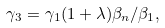Convert formula to latex. <formula><loc_0><loc_0><loc_500><loc_500>\gamma _ { 3 } = \gamma _ { 1 } ( 1 + \lambda ) \beta _ { n } / \beta _ { 1 } ,</formula> 